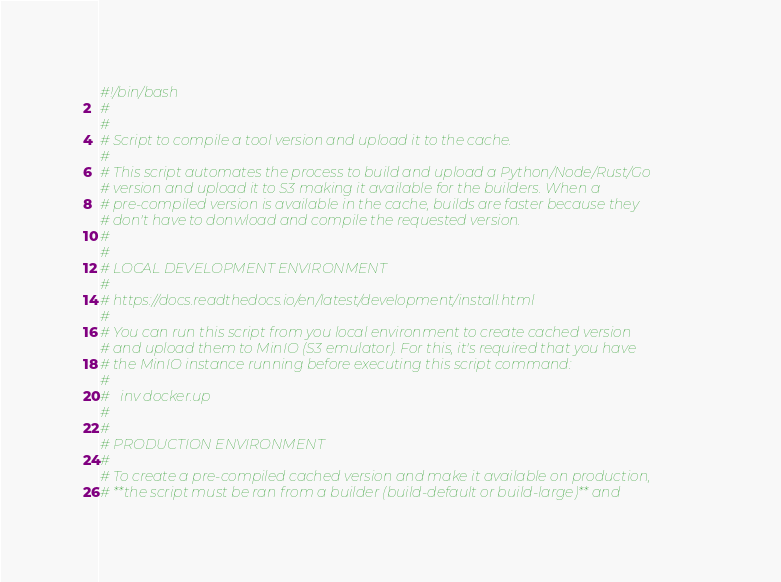<code> <loc_0><loc_0><loc_500><loc_500><_Bash_>#!/bin/bash
#
#
# Script to compile a tool version and upload it to the cache.
#
# This script automates the process to build and upload a Python/Node/Rust/Go
# version and upload it to S3 making it available for the builders. When a
# pre-compiled version is available in the cache, builds are faster because they
# don't have to donwload and compile the requested version.
#
#
# LOCAL DEVELOPMENT ENVIRONMENT
#
# https://docs.readthedocs.io/en/latest/development/install.html
#
# You can run this script from you local environment to create cached version
# and upload them to MinIO (S3 emulator). For this, it's required that you have
# the MinIO instance running before executing this script command:
#
#   inv docker.up
#
#
# PRODUCTION ENVIRONMENT
#
# To create a pre-compiled cached version and make it available on production,
# **the script must be ran from a builder (build-default or build-large)** and</code> 